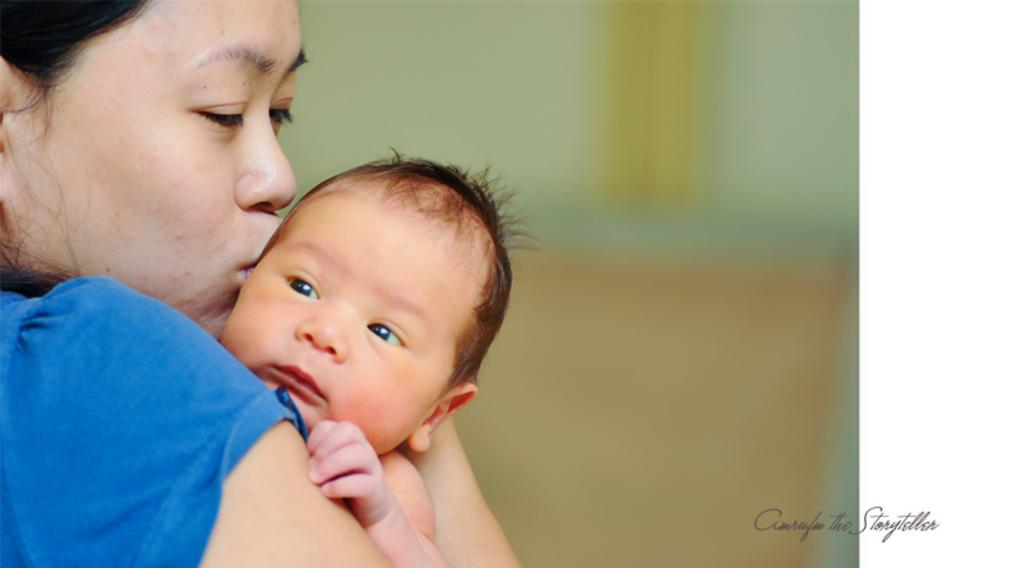Who is the main subject in the image? There is a lady in the image. What is the lady doing in the image? The lady is holding a baby. What can be seen on the right side of the image? There is text on the right side of the image. How would you describe the background of the image? The background of the image is blurred. What role does the servant play in the image? There is no servant present in the image. How does the lady contribute to society in the image? The image does not provide information about the lady's contribution to society. 